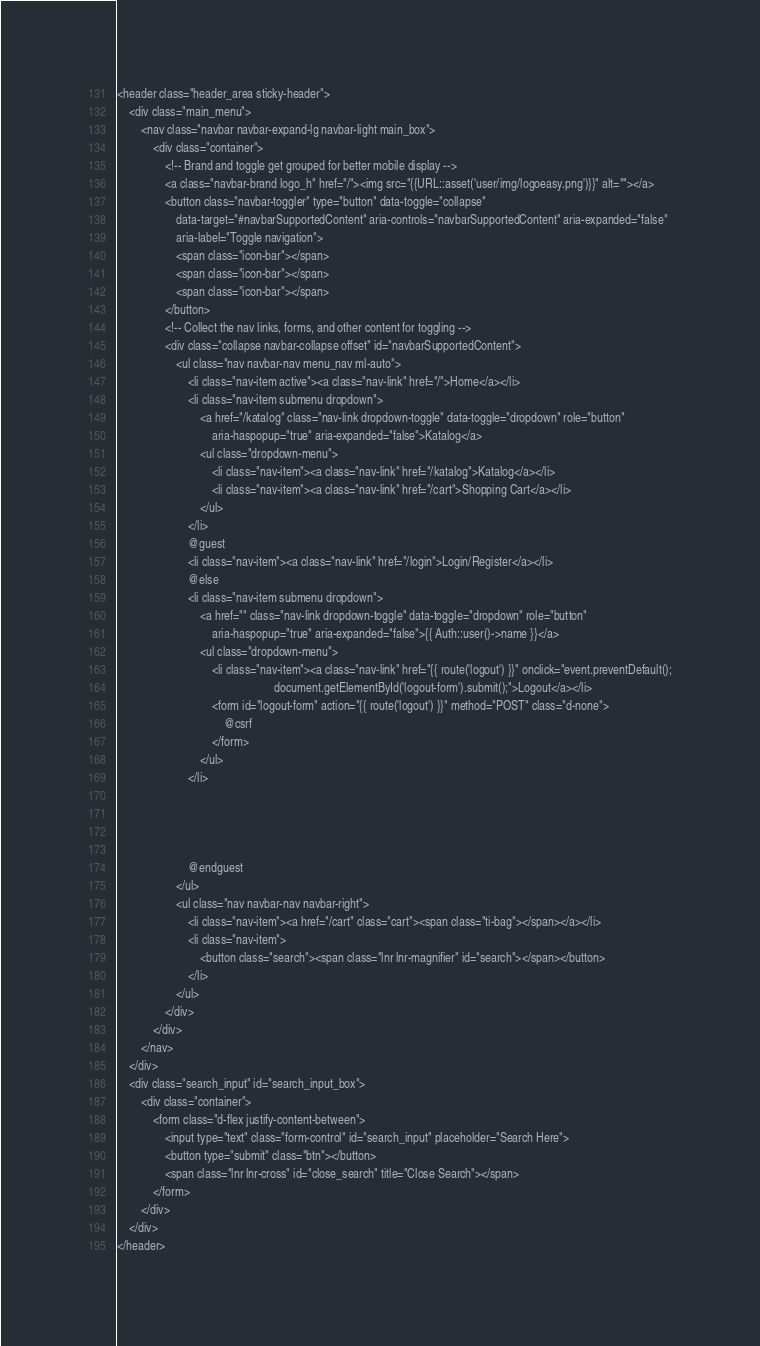<code> <loc_0><loc_0><loc_500><loc_500><_PHP_><header class="header_area sticky-header">
    <div class="main_menu">
        <nav class="navbar navbar-expand-lg navbar-light main_box">
            <div class="container">
                <!-- Brand and toggle get grouped for better mobile display -->
                <a class="navbar-brand logo_h" href="/"><img src="{{URL::asset('user/img/logoeasy.png')}}" alt=""></a>
                <button class="navbar-toggler" type="button" data-toggle="collapse"
                    data-target="#navbarSupportedContent" aria-controls="navbarSupportedContent" aria-expanded="false"
                    aria-label="Toggle navigation">
                    <span class="icon-bar"></span>
                    <span class="icon-bar"></span>
                    <span class="icon-bar"></span>
                </button>
                <!-- Collect the nav links, forms, and other content for toggling -->
                <div class="collapse navbar-collapse offset" id="navbarSupportedContent">
                    <ul class="nav navbar-nav menu_nav ml-auto">
                        <li class="nav-item active"><a class="nav-link" href="/">Home</a></li>
                        <li class="nav-item submenu dropdown">
                            <a href="/katalog" class="nav-link dropdown-toggle" data-toggle="dropdown" role="button"
                                aria-haspopup="true" aria-expanded="false">Katalog</a>
                            <ul class="dropdown-menu">
                                <li class="nav-item"><a class="nav-link" href="/katalog">Katalog</a></li>
                                <li class="nav-item"><a class="nav-link" href="/cart">Shopping Cart</a></li>
                            </ul>
                        </li>
                        @guest
                        <li class="nav-item"><a class="nav-link" href="/login">Login/Register</a></li>
                        @else
                        <li class="nav-item submenu dropdown">
                            <a href="" class="nav-link dropdown-toggle" data-toggle="dropdown" role="button"
                                aria-haspopup="true" aria-expanded="false">{{ Auth::user()->name }}</a>
                            <ul class="dropdown-menu">
                                <li class="nav-item"><a class="nav-link" href="{{ route('logout') }}" onclick="event.preventDefault();
                                                     document.getElementById('logout-form').submit();">Logout</a></li>
                                <form id="logout-form" action="{{ route('logout') }}" method="POST" class="d-none">
                                    @csrf
                                </form>
                            </ul>
                        </li>




                        @endguest
                    </ul>
                    <ul class="nav navbar-nav navbar-right">
                        <li class="nav-item"><a href="/cart" class="cart"><span class="ti-bag"></span></a></li>
                        <li class="nav-item">
                            <button class="search"><span class="lnr lnr-magnifier" id="search"></span></button>
                        </li>
                    </ul>
                </div>
            </div>
        </nav>
    </div>
    <div class="search_input" id="search_input_box">
        <div class="container">
            <form class="d-flex justify-content-between">
                <input type="text" class="form-control" id="search_input" placeholder="Search Here">
                <button type="submit" class="btn"></button>
                <span class="lnr lnr-cross" id="close_search" title="Close Search"></span>
            </form>
        </div>
    </div>
</header></code> 